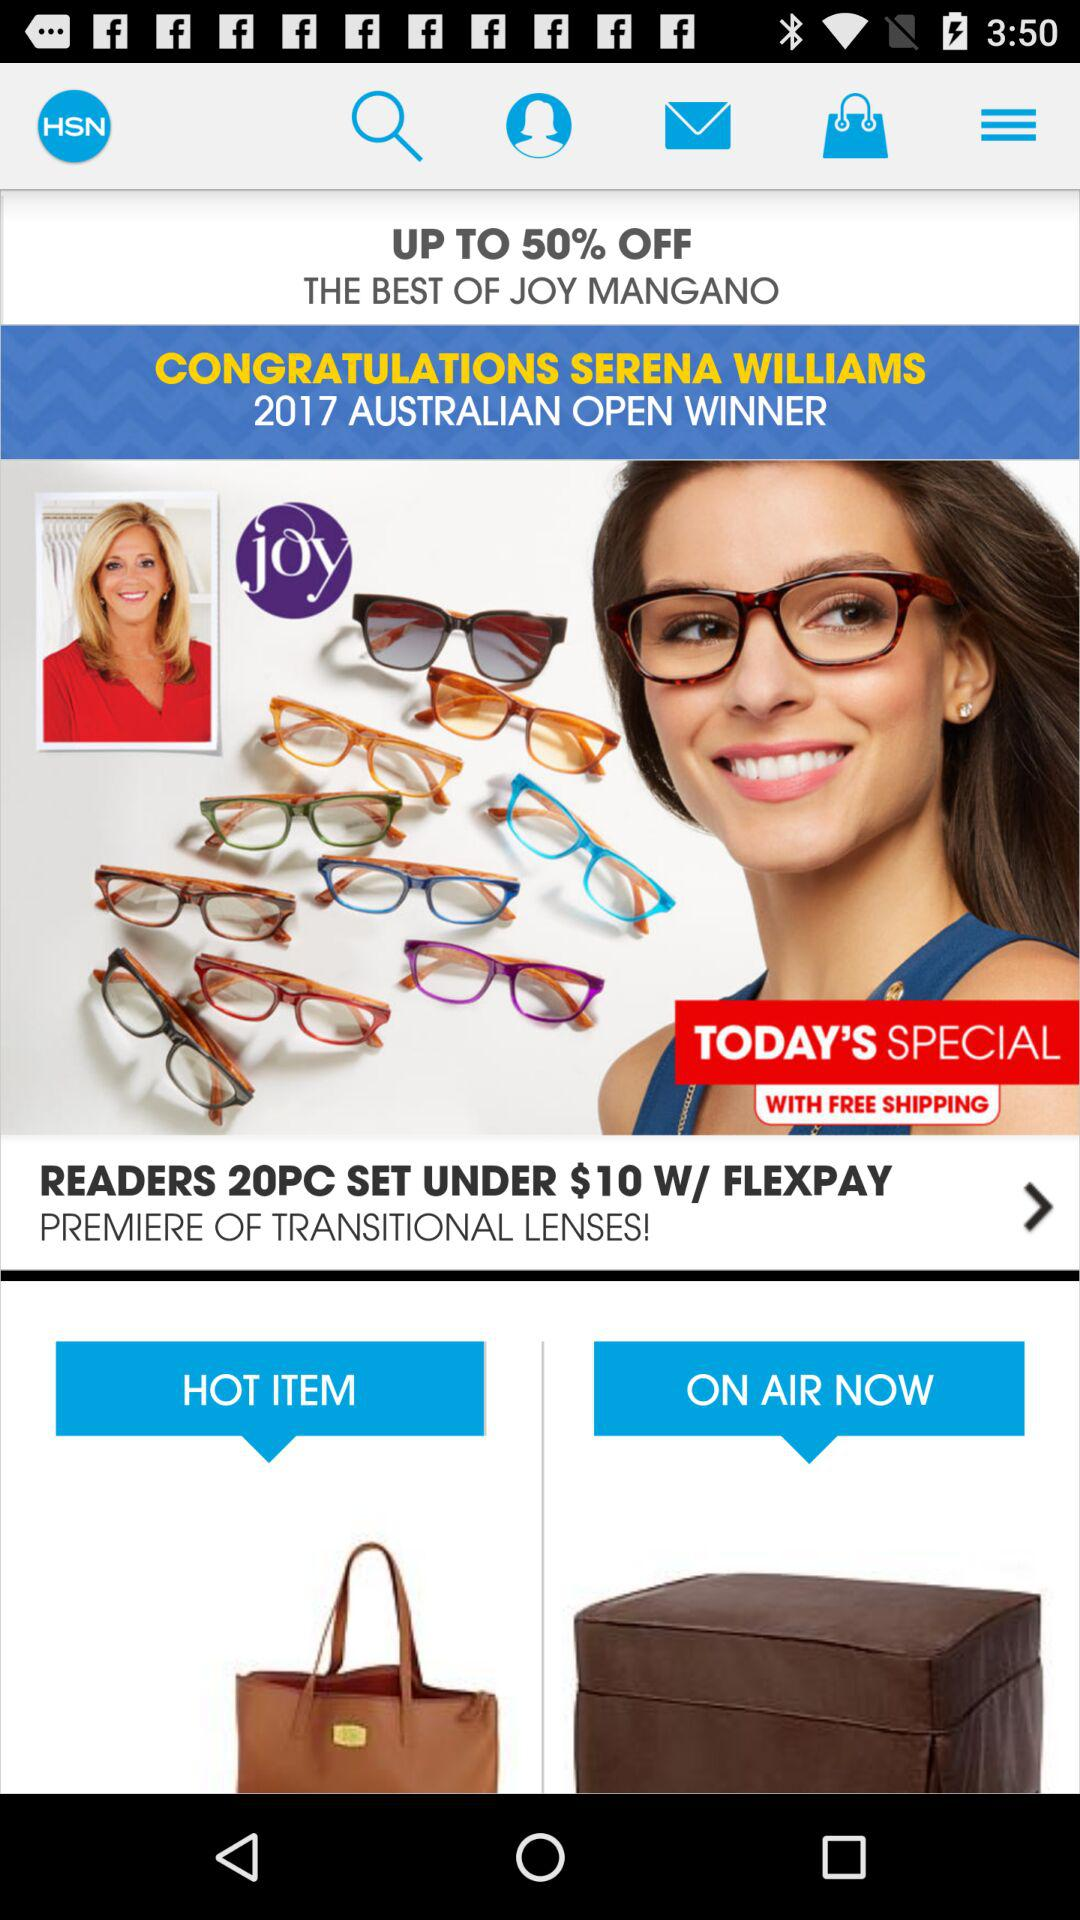What percentage is off on the product? Off on the product is upto 50%. 